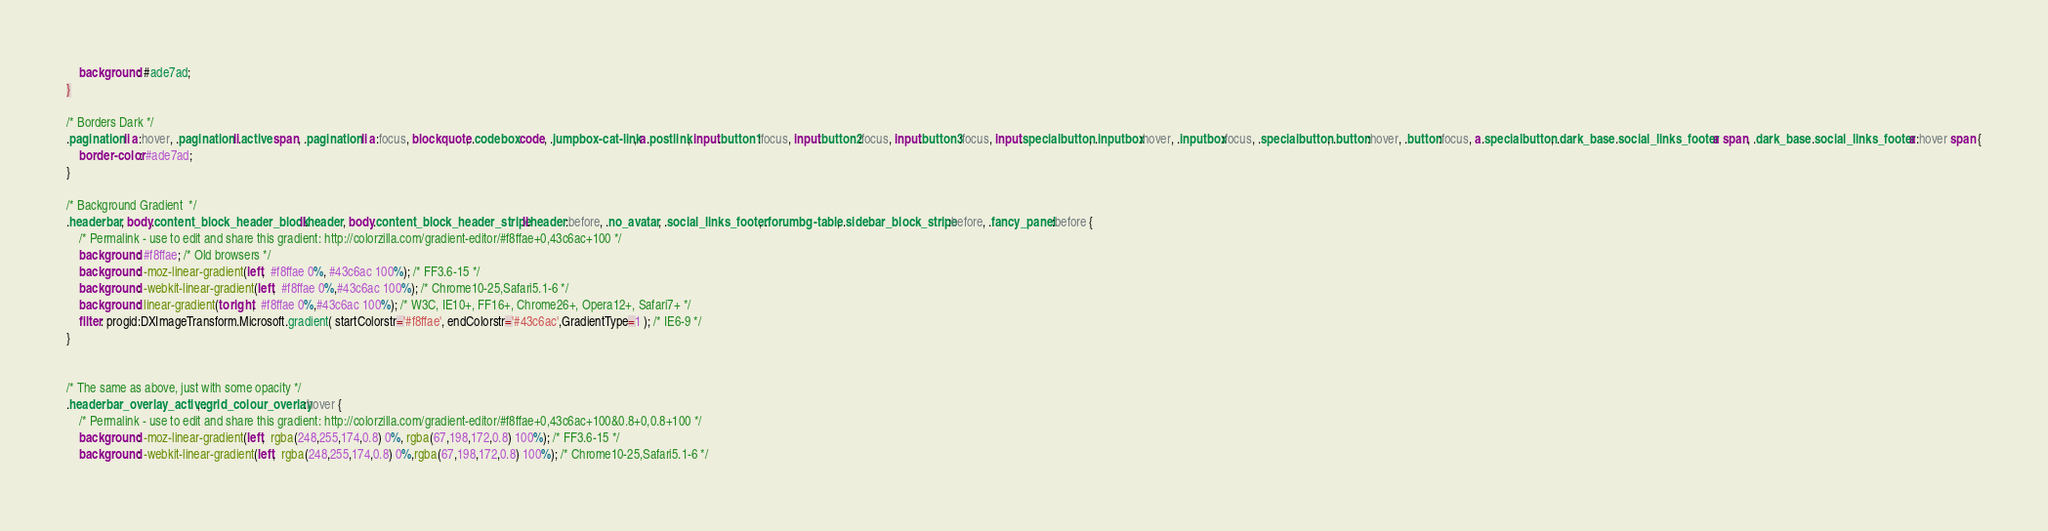<code> <loc_0><loc_0><loc_500><loc_500><_CSS_>	background: #ade7ad;	
}

/* Borders Dark */
.pagination li a:hover, .pagination li.active span, .pagination li a:focus, blockquote, .codebox code, .jumpbox-cat-link, a.postlink, input.button1:focus, input.button2:focus, input.button3:focus, input.specialbutton, .inputbox:hover, .inputbox:focus, .specialbutton, .button:hover, .button:focus, a.specialbutton, .dark_base .social_links_footer a span, .dark_base .social_links_footer a:hover span {
	border-color: #ade7ad;
}

/* Background Gradient  */
.headerbar, body.content_block_header_block li.header, body.content_block_header_stripe li.header:before, .no_avatar, .social_links_footer, .forumbg-table, .sidebar_block_stripe:before, .fancy_panel:before {
	/* Permalink - use to edit and share this gradient: http://colorzilla.com/gradient-editor/#f8ffae+0,43c6ac+100 */
	background: #f8ffae; /* Old browsers */
	background: -moz-linear-gradient(left,  #f8ffae 0%, #43c6ac 100%); /* FF3.6-15 */
	background: -webkit-linear-gradient(left,  #f8ffae 0%,#43c6ac 100%); /* Chrome10-25,Safari5.1-6 */
	background: linear-gradient(to right,  #f8ffae 0%,#43c6ac 100%); /* W3C, IE10+, FF16+, Chrome26+, Opera12+, Safari7+ */
	filter: progid:DXImageTransform.Microsoft.gradient( startColorstr='#f8ffae', endColorstr='#43c6ac',GradientType=1 ); /* IE6-9 */
}


/* The same as above, just with some opacity */
.headerbar_overlay_active, .grid_colour_overlay:hover {
	/* Permalink - use to edit and share this gradient: http://colorzilla.com/gradient-editor/#f8ffae+0,43c6ac+100&0.8+0,0.8+100 */
	background: -moz-linear-gradient(left,  rgba(248,255,174,0.8) 0%, rgba(67,198,172,0.8) 100%); /* FF3.6-15 */
	background: -webkit-linear-gradient(left,  rgba(248,255,174,0.8) 0%,rgba(67,198,172,0.8) 100%); /* Chrome10-25,Safari5.1-6 */</code> 